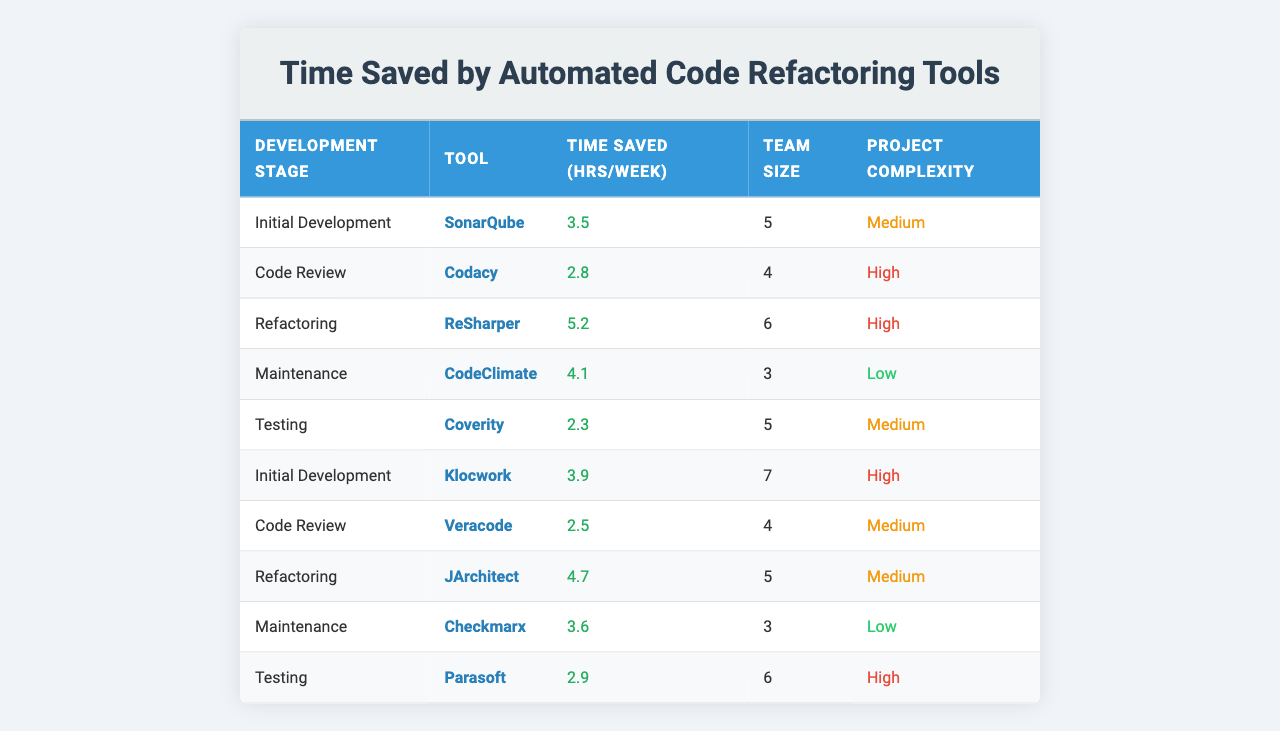What is the time saved per week by using SonarQube during the initial development stage? According to the table, SonarQube saves 3.5 hours per week during the initial development stage.
Answer: 3.5 hours How many team members were using ReSharper for refactoring? The table indicates that there were 6 team members using ReSharper for the refactoring stage.
Answer: 6 team members Which tool saves the most time during the refactoring stage? From the table, ReSharper saves the most time at 5.2 hours per week during the refactoring stage.
Answer: ReSharper What is the total time saved per week across all maintenance stages? CodeClimate saves 4.1 hours and Checkmarx saves 3.6 hours, so total time saved is 4.1 + 3.6 = 7.7 hours per week in maintenance stages.
Answer: 7.7 hours Is the project complexity for using Codacy in the code review stage classified as high? Checking the table, Codacy is associated with a high project complexity in the code review stage.
Answer: Yes What is the average time saved per week across all testing stages? Coverity saves 2.3 hours and Parasoft saves 2.9 hours, summing them gives 2.3 + 2.9 = 5.2 hours. Dividing by 2 (the number of data points) gives an average of 5.2/2 = 2.6 hours saved per week.
Answer: 2.6 hours Which development stage has the highest average time saved across all tools listed? To find the average for each development stage: Initial Development - (3.5 + 3.9) / 2 = 3.7; Code Review - (2.8 + 2.5) / 2 = 2.65; Refactoring - (5.2 + 4.7) / 2 = 4.95; Maintenance - (4.1 + 3.6) / 2 = 3.85; Testing - (2.3 + 2.9) / 2 = 2.6. The highest average time saved is for Refactoring at 4.95 hours per week.
Answer: Refactoring How does the time saved using Klocwork in initial development compare to time saved using SonarQube? Klocwork saves 3.9 hours per week and SonarQube saves 3.5 hours. 3.9 is greater than 3.5, therefore Klocwork saves more time.
Answer: Klocwork saves more time Which development stage has the lowest time saved per week, and what is that value? The lowest time saved in the table is from the testing stage using Coverity with 2.3 hours saved per week.
Answer: 2.3 hours Is there a difference in project complexity between the tools used in the testing stage? In the table, Coverity is classified as medium complexity while Parasoft is classified as high complexity. Thus, there is a difference in project complexity.
Answer: Yes 